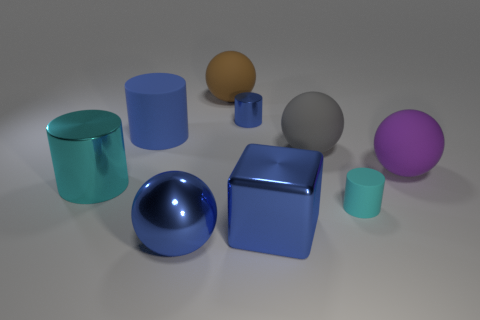Do the object that is in front of the cube and the tiny matte cylinder have the same size?
Offer a terse response. No. Is the number of blue metal blocks that are left of the tiny blue shiny cylinder less than the number of brown balls?
Ensure brevity in your answer.  Yes. How big is the rubber cylinder right of the ball that is in front of the purple matte sphere?
Your answer should be compact. Small. Is the number of red cylinders less than the number of purple rubber spheres?
Give a very brief answer. Yes. What is the material of the ball that is both on the left side of the blue metal cube and in front of the brown rubber thing?
Keep it short and to the point. Metal. Is there a gray matte thing behind the ball in front of the small matte thing?
Offer a very short reply. Yes. How many things are either blue matte things or large yellow rubber cylinders?
Offer a terse response. 1. There is a big blue object that is both in front of the large gray rubber ball and on the left side of the brown rubber object; what is its shape?
Offer a terse response. Sphere. Do the ball that is in front of the large shiny cylinder and the big blue cube have the same material?
Your answer should be compact. Yes. How many objects are big cubes or small cylinders that are in front of the purple thing?
Your response must be concise. 2. 